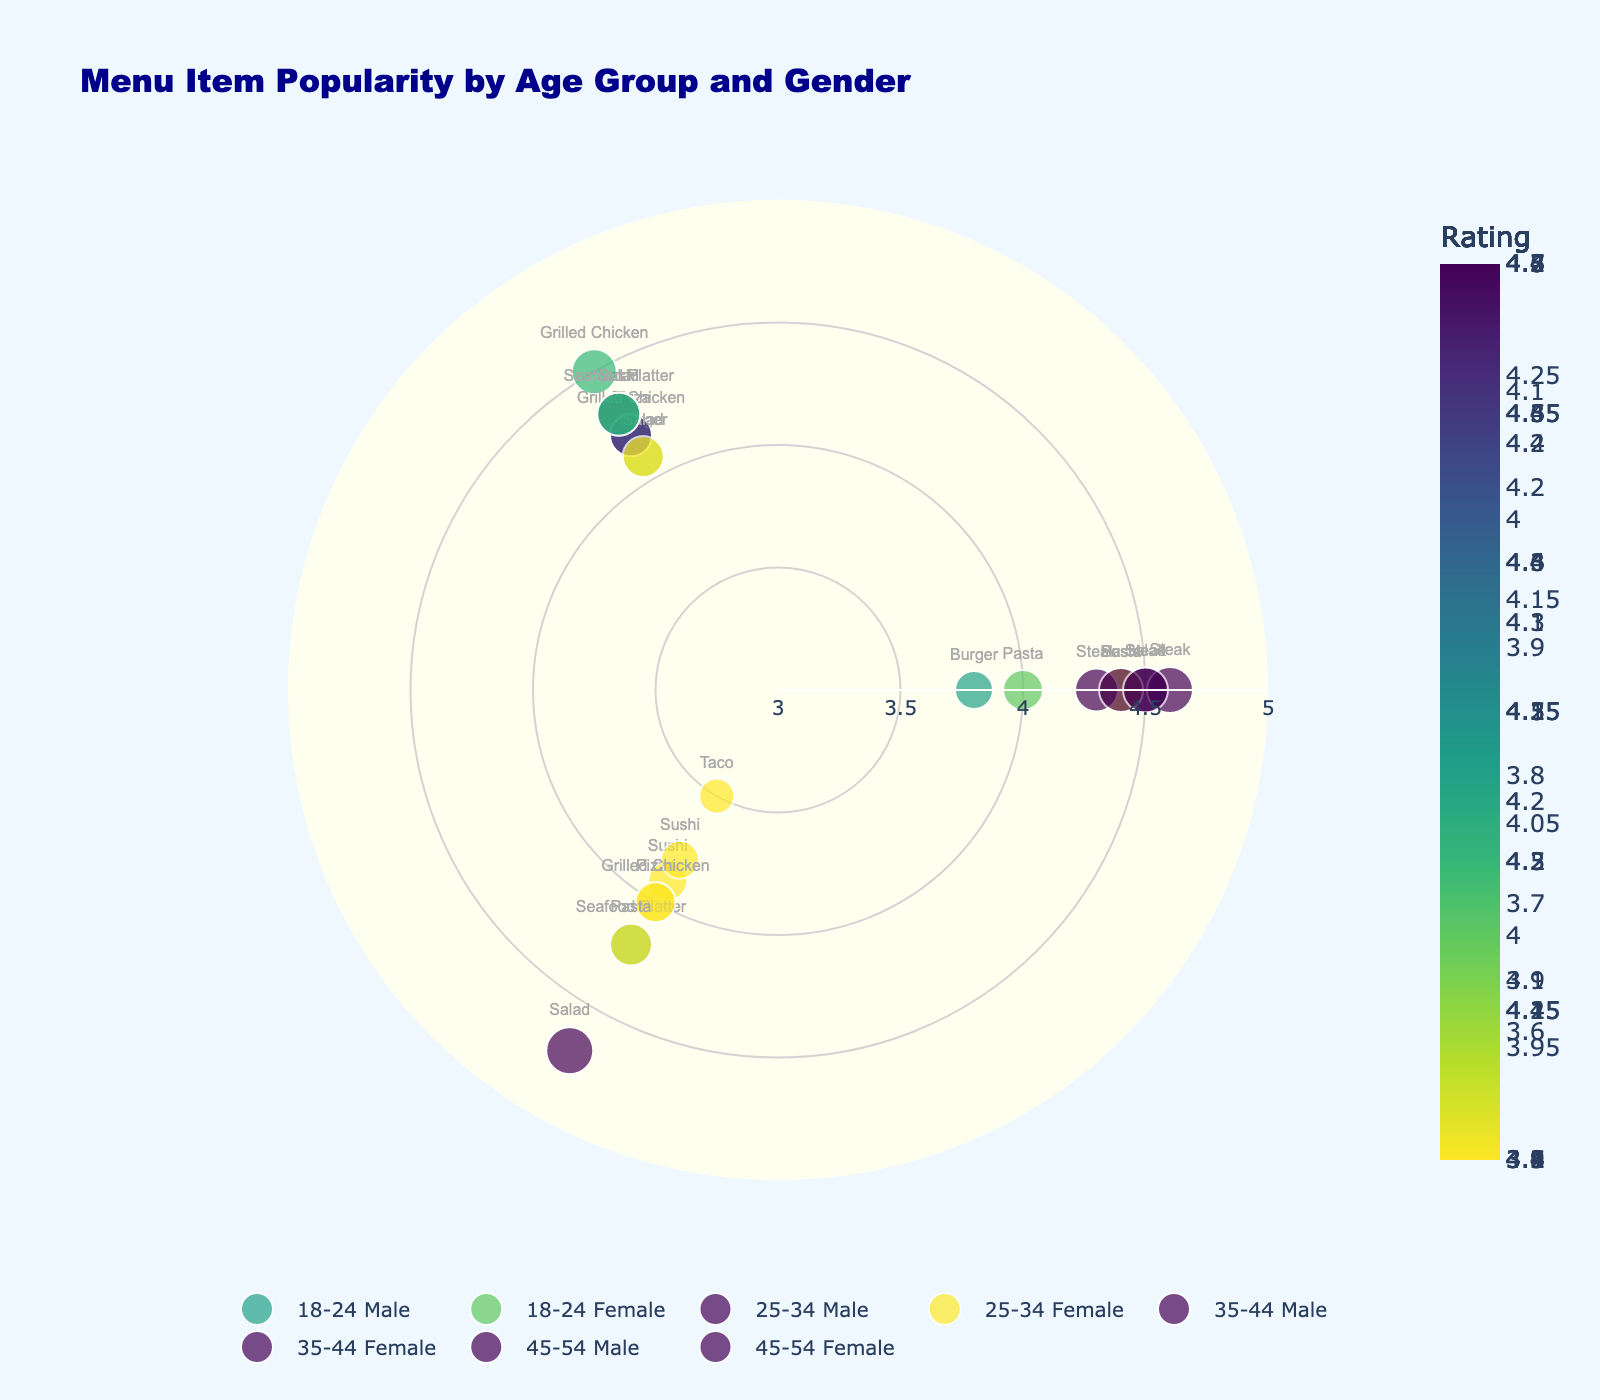What is the title of this chart? The title of the chart is usually displayed at the top, often in a larger and sometimes bold font. In this case, the title is "Menu Item Popularity by Age Group and Gender" as mentioned in the layout section.
Answer: Menu Item Popularity by Age Group and Gender Which age group has the highest average rating for Steak? To find this, identify the points labeled "Steak" and compare the radial (average rating) value. The age group 45-54 Male has the highest average rating for Steak at 4.6.
Answer: 45-54 Male How many menu items are popular among females aged 18-24? Each marker on the chart represents a menu item. By counting the markers labeled under the group 18-24 Female, you will find they include Pasta, Salad, and Sushi, totaling 3 items.
Answer: 3 What is the average rating difference between the highest and lowest ratings for menu items among Females aged 25-34? First, locate the ratings for Sushi (4.4), Grilled Chicken (4.5), and Salad (4.7). The highest is 4.7 and the lowest is 4.4. The difference is 4.7 - 4.4 = 0.3.
Answer: 0.3 Which age-gender group has the lowest average rating for any single menu item? Compare the radial positions of all points. The lowest rating is 3.5 for Tacos among 18-24 Males.
Answer: 18-24 Male Which age-gender group shows the most popularity for Salad? Look at the radial values for Salad across different groups. The highest rating for Salad is 4.7 among Females aged 25-34.
Answer: 25-34 Female What is the most popular menu item among Males aged 35-44? Identify the points related to Males aged 35-44, identify the menu items, and compare their ratings. The item with the highest rating is Steak with 4.3.
Answer: Steak How does the popularity of Sushi compare between Males aged 18-24 and Females aged 25-34? Compare the radial values for Sushi in these groups. Males aged 18-24 rate Sushi at 3.9, while Females aged 25-34 rate it at 4.4.
Answer: Females aged 25-34 rate it higher What is the range of average ratings for menu items among Females aged 35-44? Find the highest and lowest average ratings within this group: Pasta (4.4), Salad (4.1), Seafood Platter (4.2). The range is calculated as 4.4 - 4.1 = 0.3.
Answer: 0.3 